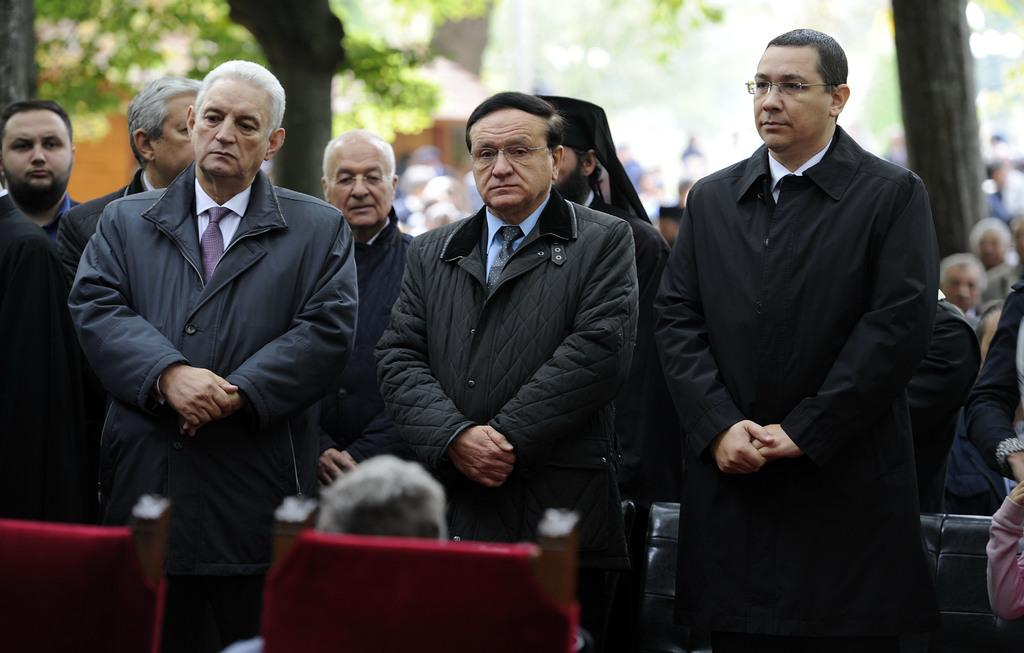What is happening in the image? There is a group of people standing together in the image. How many people are in the group? The number of people in the group is not specified, but there are many people around the group. What can be seen in the background of the image? There are trees visible in the background of the image. What type of bomb is being diffused in the image? There is no bomb present in the image; it features a group of people standing together with trees visible in the background. 